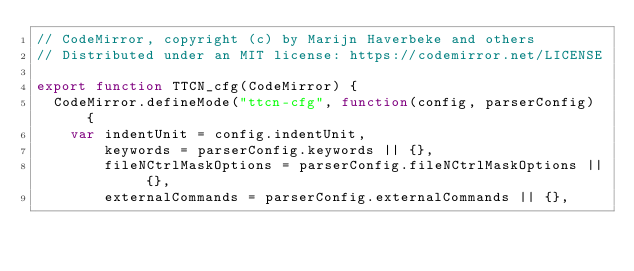<code> <loc_0><loc_0><loc_500><loc_500><_JavaScript_>// CodeMirror, copyright (c) by Marijn Haverbeke and others
// Distributed under an MIT license: https://codemirror.net/LICENSE

export function TTCN_cfg(CodeMirror) {
  CodeMirror.defineMode("ttcn-cfg", function(config, parserConfig) {
    var indentUnit = config.indentUnit,
        keywords = parserConfig.keywords || {},
        fileNCtrlMaskOptions = parserConfig.fileNCtrlMaskOptions || {},
        externalCommands = parserConfig.externalCommands || {},</code> 